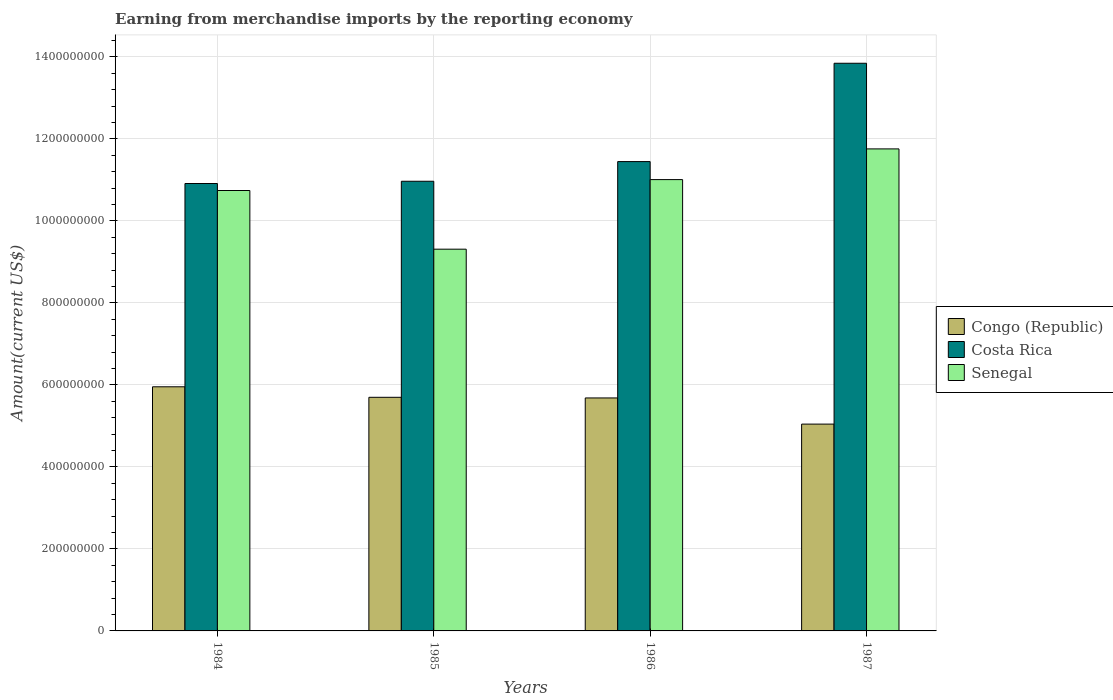How many groups of bars are there?
Ensure brevity in your answer.  4. Are the number of bars per tick equal to the number of legend labels?
Ensure brevity in your answer.  Yes. Are the number of bars on each tick of the X-axis equal?
Provide a succinct answer. Yes. How many bars are there on the 2nd tick from the right?
Keep it short and to the point. 3. In how many cases, is the number of bars for a given year not equal to the number of legend labels?
Make the answer very short. 0. What is the amount earned from merchandise imports in Congo (Republic) in 1986?
Ensure brevity in your answer.  5.68e+08. Across all years, what is the maximum amount earned from merchandise imports in Costa Rica?
Keep it short and to the point. 1.38e+09. Across all years, what is the minimum amount earned from merchandise imports in Congo (Republic)?
Your answer should be compact. 5.04e+08. In which year was the amount earned from merchandise imports in Senegal maximum?
Provide a succinct answer. 1987. In which year was the amount earned from merchandise imports in Senegal minimum?
Your answer should be very brief. 1985. What is the total amount earned from merchandise imports in Costa Rica in the graph?
Provide a short and direct response. 4.72e+09. What is the difference between the amount earned from merchandise imports in Congo (Republic) in 1986 and that in 1987?
Make the answer very short. 6.38e+07. What is the difference between the amount earned from merchandise imports in Senegal in 1986 and the amount earned from merchandise imports in Congo (Republic) in 1984?
Your response must be concise. 5.05e+08. What is the average amount earned from merchandise imports in Congo (Republic) per year?
Offer a very short reply. 5.59e+08. In the year 1986, what is the difference between the amount earned from merchandise imports in Costa Rica and amount earned from merchandise imports in Congo (Republic)?
Ensure brevity in your answer.  5.76e+08. What is the ratio of the amount earned from merchandise imports in Senegal in 1986 to that in 1987?
Your response must be concise. 0.94. Is the amount earned from merchandise imports in Senegal in 1986 less than that in 1987?
Provide a succinct answer. Yes. Is the difference between the amount earned from merchandise imports in Costa Rica in 1985 and 1987 greater than the difference between the amount earned from merchandise imports in Congo (Republic) in 1985 and 1987?
Your response must be concise. No. What is the difference between the highest and the second highest amount earned from merchandise imports in Costa Rica?
Provide a short and direct response. 2.40e+08. What is the difference between the highest and the lowest amount earned from merchandise imports in Congo (Republic)?
Give a very brief answer. 9.10e+07. What is the difference between two consecutive major ticks on the Y-axis?
Make the answer very short. 2.00e+08. Does the graph contain any zero values?
Give a very brief answer. No. How many legend labels are there?
Provide a succinct answer. 3. How are the legend labels stacked?
Ensure brevity in your answer.  Vertical. What is the title of the graph?
Offer a terse response. Earning from merchandise imports by the reporting economy. Does "Aruba" appear as one of the legend labels in the graph?
Your answer should be very brief. No. What is the label or title of the Y-axis?
Make the answer very short. Amount(current US$). What is the Amount(current US$) of Congo (Republic) in 1984?
Your response must be concise. 5.95e+08. What is the Amount(current US$) of Costa Rica in 1984?
Offer a terse response. 1.09e+09. What is the Amount(current US$) in Senegal in 1984?
Ensure brevity in your answer.  1.07e+09. What is the Amount(current US$) of Congo (Republic) in 1985?
Make the answer very short. 5.70e+08. What is the Amount(current US$) of Costa Rica in 1985?
Offer a very short reply. 1.10e+09. What is the Amount(current US$) in Senegal in 1985?
Give a very brief answer. 9.31e+08. What is the Amount(current US$) in Congo (Republic) in 1986?
Keep it short and to the point. 5.68e+08. What is the Amount(current US$) in Costa Rica in 1986?
Your response must be concise. 1.14e+09. What is the Amount(current US$) in Senegal in 1986?
Offer a very short reply. 1.10e+09. What is the Amount(current US$) in Congo (Republic) in 1987?
Provide a succinct answer. 5.04e+08. What is the Amount(current US$) in Costa Rica in 1987?
Give a very brief answer. 1.38e+09. What is the Amount(current US$) of Senegal in 1987?
Your answer should be very brief. 1.18e+09. Across all years, what is the maximum Amount(current US$) of Congo (Republic)?
Give a very brief answer. 5.95e+08. Across all years, what is the maximum Amount(current US$) of Costa Rica?
Make the answer very short. 1.38e+09. Across all years, what is the maximum Amount(current US$) in Senegal?
Offer a very short reply. 1.18e+09. Across all years, what is the minimum Amount(current US$) of Congo (Republic)?
Provide a short and direct response. 5.04e+08. Across all years, what is the minimum Amount(current US$) in Costa Rica?
Give a very brief answer. 1.09e+09. Across all years, what is the minimum Amount(current US$) in Senegal?
Your answer should be compact. 9.31e+08. What is the total Amount(current US$) of Congo (Republic) in the graph?
Your answer should be compact. 2.24e+09. What is the total Amount(current US$) in Costa Rica in the graph?
Ensure brevity in your answer.  4.72e+09. What is the total Amount(current US$) of Senegal in the graph?
Make the answer very short. 4.28e+09. What is the difference between the Amount(current US$) in Congo (Republic) in 1984 and that in 1985?
Your answer should be very brief. 2.56e+07. What is the difference between the Amount(current US$) in Costa Rica in 1984 and that in 1985?
Offer a terse response. -5.48e+06. What is the difference between the Amount(current US$) in Senegal in 1984 and that in 1985?
Keep it short and to the point. 1.43e+08. What is the difference between the Amount(current US$) of Congo (Republic) in 1984 and that in 1986?
Provide a short and direct response. 2.72e+07. What is the difference between the Amount(current US$) in Costa Rica in 1984 and that in 1986?
Offer a terse response. -5.35e+07. What is the difference between the Amount(current US$) in Senegal in 1984 and that in 1986?
Provide a short and direct response. -2.66e+07. What is the difference between the Amount(current US$) in Congo (Republic) in 1984 and that in 1987?
Make the answer very short. 9.10e+07. What is the difference between the Amount(current US$) of Costa Rica in 1984 and that in 1987?
Keep it short and to the point. -2.93e+08. What is the difference between the Amount(current US$) of Senegal in 1984 and that in 1987?
Offer a very short reply. -1.01e+08. What is the difference between the Amount(current US$) in Congo (Republic) in 1985 and that in 1986?
Make the answer very short. 1.54e+06. What is the difference between the Amount(current US$) of Costa Rica in 1985 and that in 1986?
Provide a short and direct response. -4.80e+07. What is the difference between the Amount(current US$) of Senegal in 1985 and that in 1986?
Ensure brevity in your answer.  -1.70e+08. What is the difference between the Amount(current US$) of Congo (Republic) in 1985 and that in 1987?
Give a very brief answer. 6.53e+07. What is the difference between the Amount(current US$) of Costa Rica in 1985 and that in 1987?
Offer a terse response. -2.88e+08. What is the difference between the Amount(current US$) in Senegal in 1985 and that in 1987?
Make the answer very short. -2.45e+08. What is the difference between the Amount(current US$) of Congo (Republic) in 1986 and that in 1987?
Offer a terse response. 6.38e+07. What is the difference between the Amount(current US$) in Costa Rica in 1986 and that in 1987?
Offer a very short reply. -2.40e+08. What is the difference between the Amount(current US$) of Senegal in 1986 and that in 1987?
Keep it short and to the point. -7.49e+07. What is the difference between the Amount(current US$) of Congo (Republic) in 1984 and the Amount(current US$) of Costa Rica in 1985?
Your answer should be compact. -5.01e+08. What is the difference between the Amount(current US$) in Congo (Republic) in 1984 and the Amount(current US$) in Senegal in 1985?
Your answer should be compact. -3.36e+08. What is the difference between the Amount(current US$) in Costa Rica in 1984 and the Amount(current US$) in Senegal in 1985?
Provide a succinct answer. 1.60e+08. What is the difference between the Amount(current US$) of Congo (Republic) in 1984 and the Amount(current US$) of Costa Rica in 1986?
Provide a succinct answer. -5.49e+08. What is the difference between the Amount(current US$) of Congo (Republic) in 1984 and the Amount(current US$) of Senegal in 1986?
Ensure brevity in your answer.  -5.05e+08. What is the difference between the Amount(current US$) of Costa Rica in 1984 and the Amount(current US$) of Senegal in 1986?
Provide a short and direct response. -9.52e+06. What is the difference between the Amount(current US$) of Congo (Republic) in 1984 and the Amount(current US$) of Costa Rica in 1987?
Your answer should be very brief. -7.89e+08. What is the difference between the Amount(current US$) in Congo (Republic) in 1984 and the Amount(current US$) in Senegal in 1987?
Make the answer very short. -5.80e+08. What is the difference between the Amount(current US$) in Costa Rica in 1984 and the Amount(current US$) in Senegal in 1987?
Your answer should be compact. -8.44e+07. What is the difference between the Amount(current US$) in Congo (Republic) in 1985 and the Amount(current US$) in Costa Rica in 1986?
Keep it short and to the point. -5.75e+08. What is the difference between the Amount(current US$) in Congo (Republic) in 1985 and the Amount(current US$) in Senegal in 1986?
Your response must be concise. -5.31e+08. What is the difference between the Amount(current US$) in Costa Rica in 1985 and the Amount(current US$) in Senegal in 1986?
Offer a very short reply. -4.04e+06. What is the difference between the Amount(current US$) of Congo (Republic) in 1985 and the Amount(current US$) of Costa Rica in 1987?
Offer a terse response. -8.15e+08. What is the difference between the Amount(current US$) of Congo (Republic) in 1985 and the Amount(current US$) of Senegal in 1987?
Your response must be concise. -6.06e+08. What is the difference between the Amount(current US$) in Costa Rica in 1985 and the Amount(current US$) in Senegal in 1987?
Keep it short and to the point. -7.89e+07. What is the difference between the Amount(current US$) of Congo (Republic) in 1986 and the Amount(current US$) of Costa Rica in 1987?
Provide a short and direct response. -8.16e+08. What is the difference between the Amount(current US$) in Congo (Republic) in 1986 and the Amount(current US$) in Senegal in 1987?
Your answer should be very brief. -6.07e+08. What is the difference between the Amount(current US$) of Costa Rica in 1986 and the Amount(current US$) of Senegal in 1987?
Offer a terse response. -3.10e+07. What is the average Amount(current US$) in Congo (Republic) per year?
Make the answer very short. 5.59e+08. What is the average Amount(current US$) of Costa Rica per year?
Ensure brevity in your answer.  1.18e+09. What is the average Amount(current US$) of Senegal per year?
Your answer should be very brief. 1.07e+09. In the year 1984, what is the difference between the Amount(current US$) in Congo (Republic) and Amount(current US$) in Costa Rica?
Give a very brief answer. -4.96e+08. In the year 1984, what is the difference between the Amount(current US$) in Congo (Republic) and Amount(current US$) in Senegal?
Provide a succinct answer. -4.79e+08. In the year 1984, what is the difference between the Amount(current US$) of Costa Rica and Amount(current US$) of Senegal?
Make the answer very short. 1.71e+07. In the year 1985, what is the difference between the Amount(current US$) in Congo (Republic) and Amount(current US$) in Costa Rica?
Offer a very short reply. -5.27e+08. In the year 1985, what is the difference between the Amount(current US$) in Congo (Republic) and Amount(current US$) in Senegal?
Provide a short and direct response. -3.61e+08. In the year 1985, what is the difference between the Amount(current US$) of Costa Rica and Amount(current US$) of Senegal?
Provide a short and direct response. 1.66e+08. In the year 1986, what is the difference between the Amount(current US$) of Congo (Republic) and Amount(current US$) of Costa Rica?
Your answer should be very brief. -5.76e+08. In the year 1986, what is the difference between the Amount(current US$) of Congo (Republic) and Amount(current US$) of Senegal?
Provide a succinct answer. -5.33e+08. In the year 1986, what is the difference between the Amount(current US$) of Costa Rica and Amount(current US$) of Senegal?
Your answer should be very brief. 4.39e+07. In the year 1987, what is the difference between the Amount(current US$) of Congo (Republic) and Amount(current US$) of Costa Rica?
Make the answer very short. -8.80e+08. In the year 1987, what is the difference between the Amount(current US$) in Congo (Republic) and Amount(current US$) in Senegal?
Give a very brief answer. -6.71e+08. In the year 1987, what is the difference between the Amount(current US$) of Costa Rica and Amount(current US$) of Senegal?
Provide a short and direct response. 2.09e+08. What is the ratio of the Amount(current US$) of Congo (Republic) in 1984 to that in 1985?
Make the answer very short. 1.04. What is the ratio of the Amount(current US$) of Senegal in 1984 to that in 1985?
Your answer should be very brief. 1.15. What is the ratio of the Amount(current US$) of Congo (Republic) in 1984 to that in 1986?
Give a very brief answer. 1.05. What is the ratio of the Amount(current US$) of Costa Rica in 1984 to that in 1986?
Provide a short and direct response. 0.95. What is the ratio of the Amount(current US$) in Senegal in 1984 to that in 1986?
Provide a succinct answer. 0.98. What is the ratio of the Amount(current US$) of Congo (Republic) in 1984 to that in 1987?
Provide a succinct answer. 1.18. What is the ratio of the Amount(current US$) in Costa Rica in 1984 to that in 1987?
Offer a very short reply. 0.79. What is the ratio of the Amount(current US$) of Senegal in 1984 to that in 1987?
Keep it short and to the point. 0.91. What is the ratio of the Amount(current US$) of Congo (Republic) in 1985 to that in 1986?
Ensure brevity in your answer.  1. What is the ratio of the Amount(current US$) in Costa Rica in 1985 to that in 1986?
Provide a short and direct response. 0.96. What is the ratio of the Amount(current US$) in Senegal in 1985 to that in 1986?
Your response must be concise. 0.85. What is the ratio of the Amount(current US$) of Congo (Republic) in 1985 to that in 1987?
Your answer should be compact. 1.13. What is the ratio of the Amount(current US$) of Costa Rica in 1985 to that in 1987?
Ensure brevity in your answer.  0.79. What is the ratio of the Amount(current US$) of Senegal in 1985 to that in 1987?
Your answer should be compact. 0.79. What is the ratio of the Amount(current US$) in Congo (Republic) in 1986 to that in 1987?
Provide a short and direct response. 1.13. What is the ratio of the Amount(current US$) of Costa Rica in 1986 to that in 1987?
Offer a very short reply. 0.83. What is the ratio of the Amount(current US$) in Senegal in 1986 to that in 1987?
Offer a terse response. 0.94. What is the difference between the highest and the second highest Amount(current US$) in Congo (Republic)?
Provide a short and direct response. 2.56e+07. What is the difference between the highest and the second highest Amount(current US$) in Costa Rica?
Give a very brief answer. 2.40e+08. What is the difference between the highest and the second highest Amount(current US$) in Senegal?
Your answer should be very brief. 7.49e+07. What is the difference between the highest and the lowest Amount(current US$) of Congo (Republic)?
Keep it short and to the point. 9.10e+07. What is the difference between the highest and the lowest Amount(current US$) in Costa Rica?
Provide a succinct answer. 2.93e+08. What is the difference between the highest and the lowest Amount(current US$) in Senegal?
Make the answer very short. 2.45e+08. 